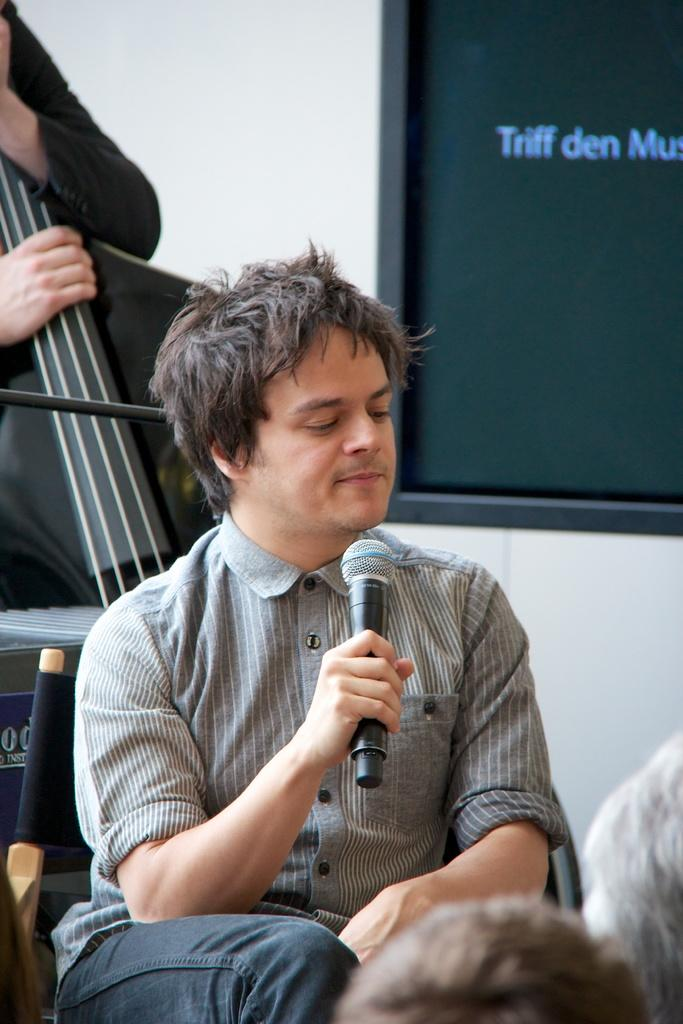What is the man in the image doing? The man is sitting on a chair and holding a microphone in the image. Who else is present in the image? There is a person holding a guitar in the image. What can be seen attached to a wall in the image? There is a board attached to a wall in the image. What type of loaf is being used as a prop in the image? There is no loaf present in the image; it features a man holding a microphone and a person holding a guitar, along with a board attached to a wall. 